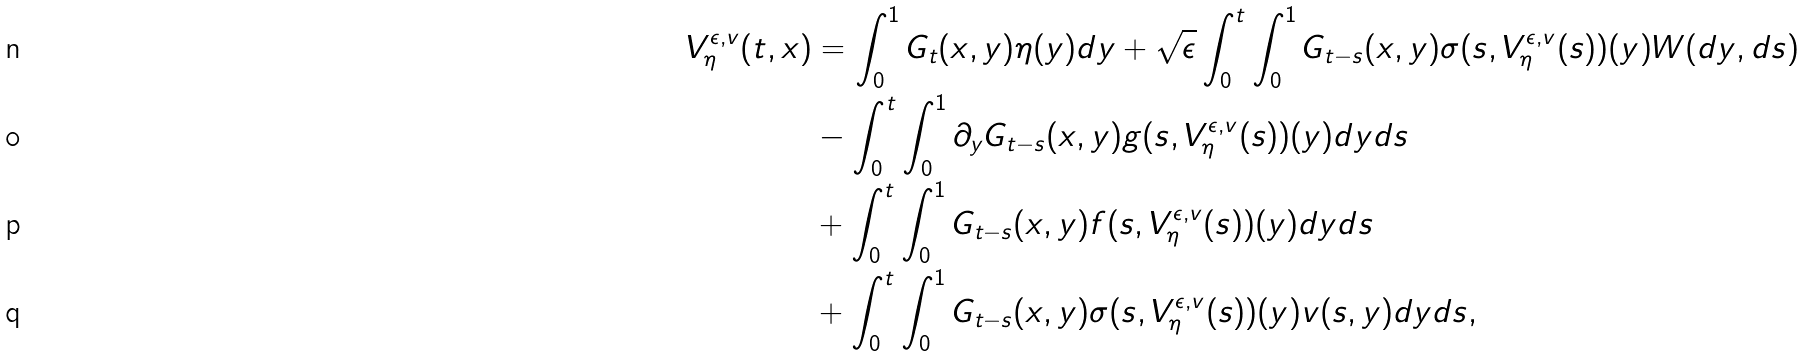<formula> <loc_0><loc_0><loc_500><loc_500>V ^ { \epsilon , v } _ { \eta } ( t , x ) & = \int _ { 0 } ^ { 1 } G _ { t } ( x , y ) \eta ( y ) d y + \sqrt { \epsilon } \int _ { 0 } ^ { t } \int _ { 0 } ^ { 1 } G _ { t - s } ( x , y ) \sigma ( s , V ^ { \epsilon , v } _ { \eta } ( s ) ) ( y ) W ( d y , d s ) \\ & - \int _ { 0 } ^ { t } \int _ { 0 } ^ { 1 } \partial _ { y } G _ { t - s } ( x , y ) g ( s , V ^ { \epsilon , v } _ { \eta } ( s ) ) ( y ) d y d s \\ & + \int _ { 0 } ^ { t } \int _ { 0 } ^ { 1 } G _ { t - s } ( x , y ) f ( s , V ^ { \epsilon , v } _ { \eta } ( s ) ) ( y ) d y d s \\ & + \int _ { 0 } ^ { t } \int _ { 0 } ^ { 1 } G _ { t - s } ( x , y ) \sigma ( s , V ^ { \epsilon , v } _ { \eta } ( s ) ) ( y ) v ( s , y ) d y d s ,</formula> 